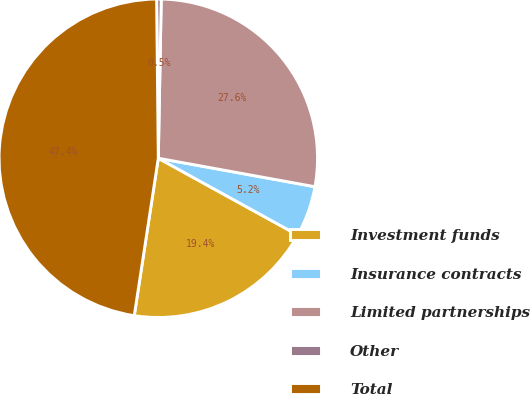Convert chart. <chart><loc_0><loc_0><loc_500><loc_500><pie_chart><fcel>Investment funds<fcel>Insurance contracts<fcel>Limited partnerships<fcel>Other<fcel>Total<nl><fcel>19.4%<fcel>5.15%<fcel>27.57%<fcel>0.46%<fcel>47.42%<nl></chart> 